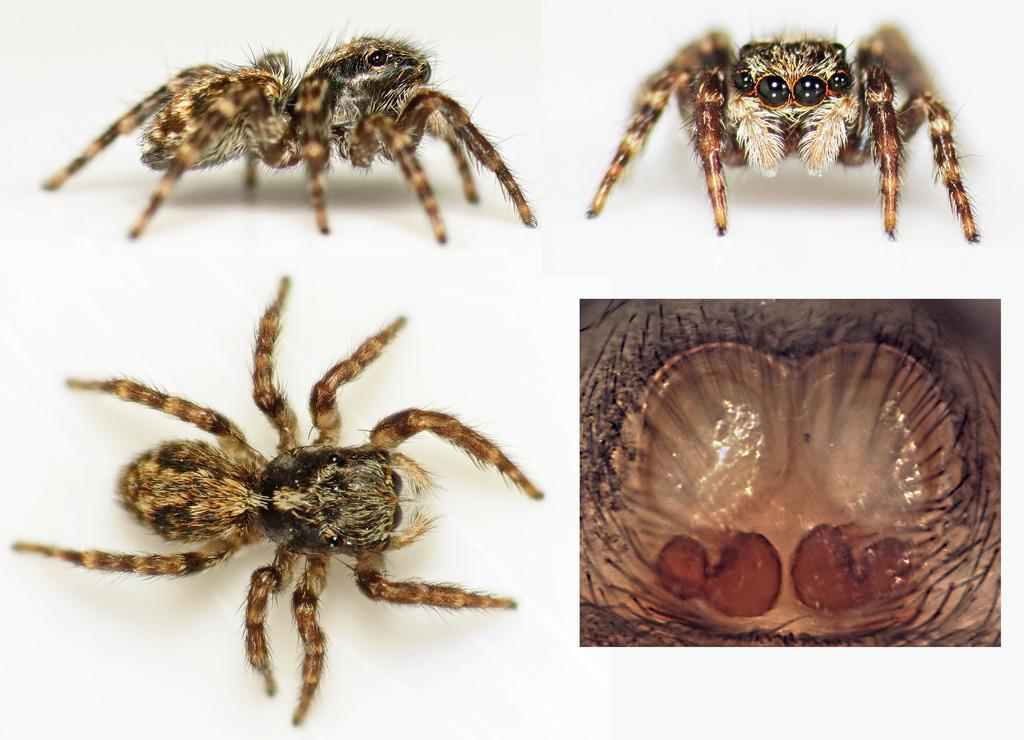How many collage frames are present in the image? There are four collage frames in the image. What is depicted in the top left and bottom left frames? Pictures of a spider are present in the top left and bottom left frames. What type of photo is in the bottom right frame? There is a micro photo of a spider in the bottom right frame. What type of truck is visible in the image? There is no truck present in the image. How many divisions are there in the collage frames? The question of divisions is not relevant to the image, as the focus is on the content of the frames, not their structure. 